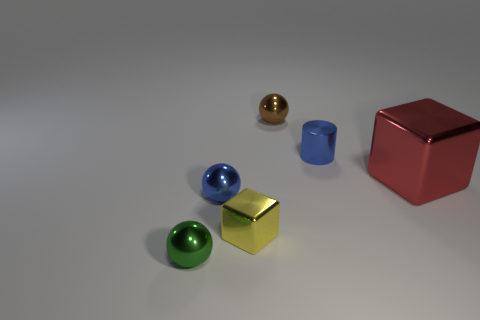Add 2 big brown metal balls. How many objects exist? 8 Subtract all yellow cubes. How many cubes are left? 1 Subtract all cylinders. How many objects are left? 5 Subtract 1 blue spheres. How many objects are left? 5 Subtract all red spheres. Subtract all brown blocks. How many spheres are left? 3 Subtract all green spheres. How many gray blocks are left? 0 Subtract all green balls. Subtract all big objects. How many objects are left? 4 Add 4 blue metal things. How many blue metal things are left? 6 Add 6 large purple blocks. How many large purple blocks exist? 6 